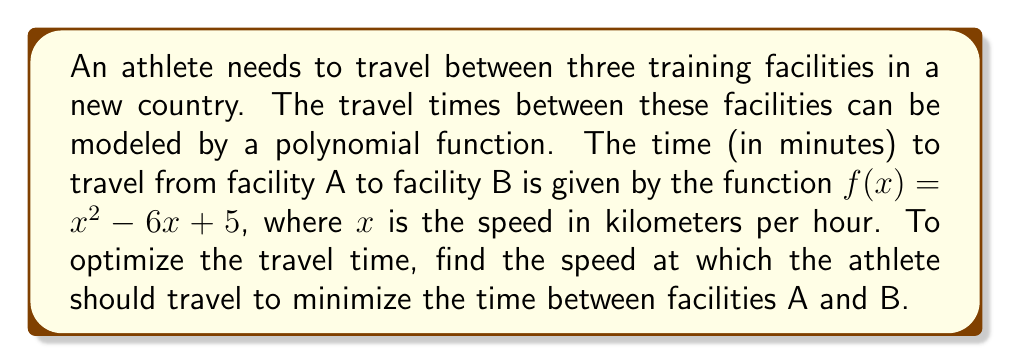Could you help me with this problem? To find the minimum value of the function $f(x) = x^2 - 6x + 5$, we need to follow these steps:

1) The minimum of a quadratic function occurs at the vertex of the parabola. The x-coordinate of the vertex gives us the optimal speed.

2) For a quadratic function in the form $f(x) = ax^2 + bx + c$, the x-coordinate of the vertex is given by $x = -\frac{b}{2a}$.

3) In our case, $a = 1$, $b = -6$, and $c = 5$. Let's substitute these values:

   $x = -\frac{(-6)}{2(1)} = \frac{6}{2} = 3$

4) To verify this is indeed a minimum (and not a maximum), we can check that $a > 0$, which it is $(a = 1)$.

5) Therefore, the optimal speed is 3 km/h.

6) We can calculate the minimum time by substituting this value back into the original function:

   $f(3) = 3^2 - 6(3) + 5 = 9 - 18 + 5 = -4$

However, since time cannot be negative, this result suggests that our polynomial model has limitations and is only valid for a certain range of speeds. In a real-world scenario, we would need to consider these limitations and possibly adjust our model.
Answer: The optimal speed to minimize travel time between facilities A and B is 3 km/h. 